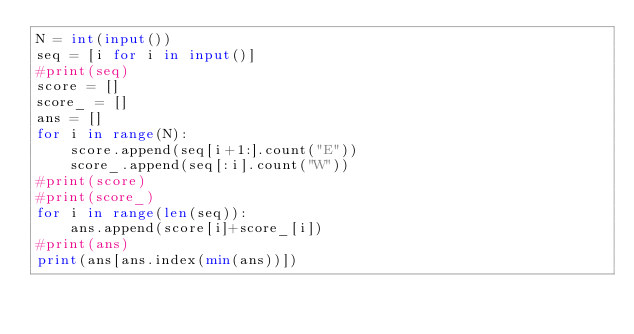<code> <loc_0><loc_0><loc_500><loc_500><_Python_>N = int(input())
seq = [i for i in input()]
#print(seq)
score = []
score_ = []
ans = []
for i in range(N):
    score.append(seq[i+1:].count("E"))
    score_.append(seq[:i].count("W"))
#print(score)
#print(score_)
for i in range(len(seq)):
    ans.append(score[i]+score_[i])
#print(ans)
print(ans[ans.index(min(ans))])</code> 